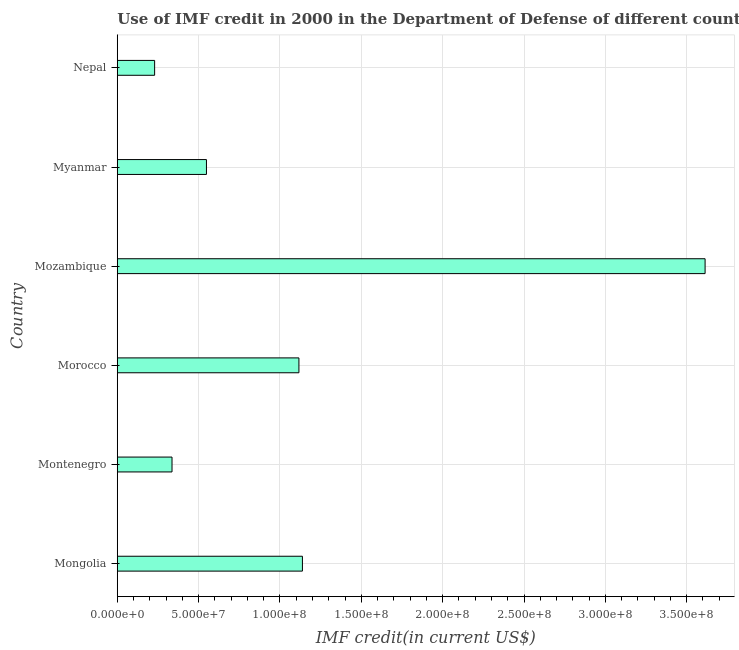Does the graph contain grids?
Your response must be concise. Yes. What is the title of the graph?
Your answer should be very brief. Use of IMF credit in 2000 in the Department of Defense of different countries. What is the label or title of the X-axis?
Provide a succinct answer. IMF credit(in current US$). What is the use of imf credit in dod in Montenegro?
Provide a succinct answer. 3.36e+07. Across all countries, what is the maximum use of imf credit in dod?
Make the answer very short. 3.61e+08. Across all countries, what is the minimum use of imf credit in dod?
Make the answer very short. 2.30e+07. In which country was the use of imf credit in dod maximum?
Offer a terse response. Mozambique. In which country was the use of imf credit in dod minimum?
Keep it short and to the point. Nepal. What is the sum of the use of imf credit in dod?
Offer a terse response. 6.98e+08. What is the difference between the use of imf credit in dod in Mongolia and Nepal?
Keep it short and to the point. 9.08e+07. What is the average use of imf credit in dod per country?
Ensure brevity in your answer.  1.16e+08. What is the median use of imf credit in dod?
Provide a succinct answer. 8.32e+07. What is the ratio of the use of imf credit in dod in Myanmar to that in Nepal?
Give a very brief answer. 2.39. What is the difference between the highest and the second highest use of imf credit in dod?
Provide a short and direct response. 2.48e+08. Is the sum of the use of imf credit in dod in Mongolia and Myanmar greater than the maximum use of imf credit in dod across all countries?
Provide a short and direct response. No. What is the difference between the highest and the lowest use of imf credit in dod?
Provide a succinct answer. 3.38e+08. In how many countries, is the use of imf credit in dod greater than the average use of imf credit in dod taken over all countries?
Your response must be concise. 1. How many countries are there in the graph?
Keep it short and to the point. 6. What is the IMF credit(in current US$) of Mongolia?
Offer a terse response. 1.14e+08. What is the IMF credit(in current US$) in Montenegro?
Keep it short and to the point. 3.36e+07. What is the IMF credit(in current US$) of Morocco?
Give a very brief answer. 1.12e+08. What is the IMF credit(in current US$) in Mozambique?
Give a very brief answer. 3.61e+08. What is the IMF credit(in current US$) of Myanmar?
Your answer should be very brief. 5.48e+07. What is the IMF credit(in current US$) of Nepal?
Ensure brevity in your answer.  2.30e+07. What is the difference between the IMF credit(in current US$) in Mongolia and Montenegro?
Your answer should be compact. 8.02e+07. What is the difference between the IMF credit(in current US$) in Mongolia and Morocco?
Your answer should be very brief. 2.15e+06. What is the difference between the IMF credit(in current US$) in Mongolia and Mozambique?
Provide a succinct answer. -2.48e+08. What is the difference between the IMF credit(in current US$) in Mongolia and Myanmar?
Give a very brief answer. 5.90e+07. What is the difference between the IMF credit(in current US$) in Mongolia and Nepal?
Offer a very short reply. 9.08e+07. What is the difference between the IMF credit(in current US$) in Montenegro and Morocco?
Offer a terse response. -7.80e+07. What is the difference between the IMF credit(in current US$) in Montenegro and Mozambique?
Make the answer very short. -3.28e+08. What is the difference between the IMF credit(in current US$) in Montenegro and Myanmar?
Your answer should be very brief. -2.12e+07. What is the difference between the IMF credit(in current US$) in Montenegro and Nepal?
Your response must be concise. 1.07e+07. What is the difference between the IMF credit(in current US$) in Morocco and Mozambique?
Give a very brief answer. -2.50e+08. What is the difference between the IMF credit(in current US$) in Morocco and Myanmar?
Your answer should be very brief. 5.68e+07. What is the difference between the IMF credit(in current US$) in Morocco and Nepal?
Keep it short and to the point. 8.87e+07. What is the difference between the IMF credit(in current US$) in Mozambique and Myanmar?
Provide a short and direct response. 3.06e+08. What is the difference between the IMF credit(in current US$) in Mozambique and Nepal?
Provide a short and direct response. 3.38e+08. What is the difference between the IMF credit(in current US$) in Myanmar and Nepal?
Make the answer very short. 3.19e+07. What is the ratio of the IMF credit(in current US$) in Mongolia to that in Montenegro?
Make the answer very short. 3.38. What is the ratio of the IMF credit(in current US$) in Mongolia to that in Mozambique?
Keep it short and to the point. 0.32. What is the ratio of the IMF credit(in current US$) in Mongolia to that in Myanmar?
Your response must be concise. 2.08. What is the ratio of the IMF credit(in current US$) in Mongolia to that in Nepal?
Keep it short and to the point. 4.96. What is the ratio of the IMF credit(in current US$) in Montenegro to that in Morocco?
Make the answer very short. 0.3. What is the ratio of the IMF credit(in current US$) in Montenegro to that in Mozambique?
Make the answer very short. 0.09. What is the ratio of the IMF credit(in current US$) in Montenegro to that in Myanmar?
Offer a terse response. 0.61. What is the ratio of the IMF credit(in current US$) in Montenegro to that in Nepal?
Your answer should be very brief. 1.47. What is the ratio of the IMF credit(in current US$) in Morocco to that in Mozambique?
Ensure brevity in your answer.  0.31. What is the ratio of the IMF credit(in current US$) in Morocco to that in Myanmar?
Your response must be concise. 2.04. What is the ratio of the IMF credit(in current US$) in Morocco to that in Nepal?
Your answer should be very brief. 4.86. What is the ratio of the IMF credit(in current US$) in Mozambique to that in Myanmar?
Provide a short and direct response. 6.59. What is the ratio of the IMF credit(in current US$) in Mozambique to that in Nepal?
Ensure brevity in your answer.  15.74. What is the ratio of the IMF credit(in current US$) in Myanmar to that in Nepal?
Offer a very short reply. 2.39. 